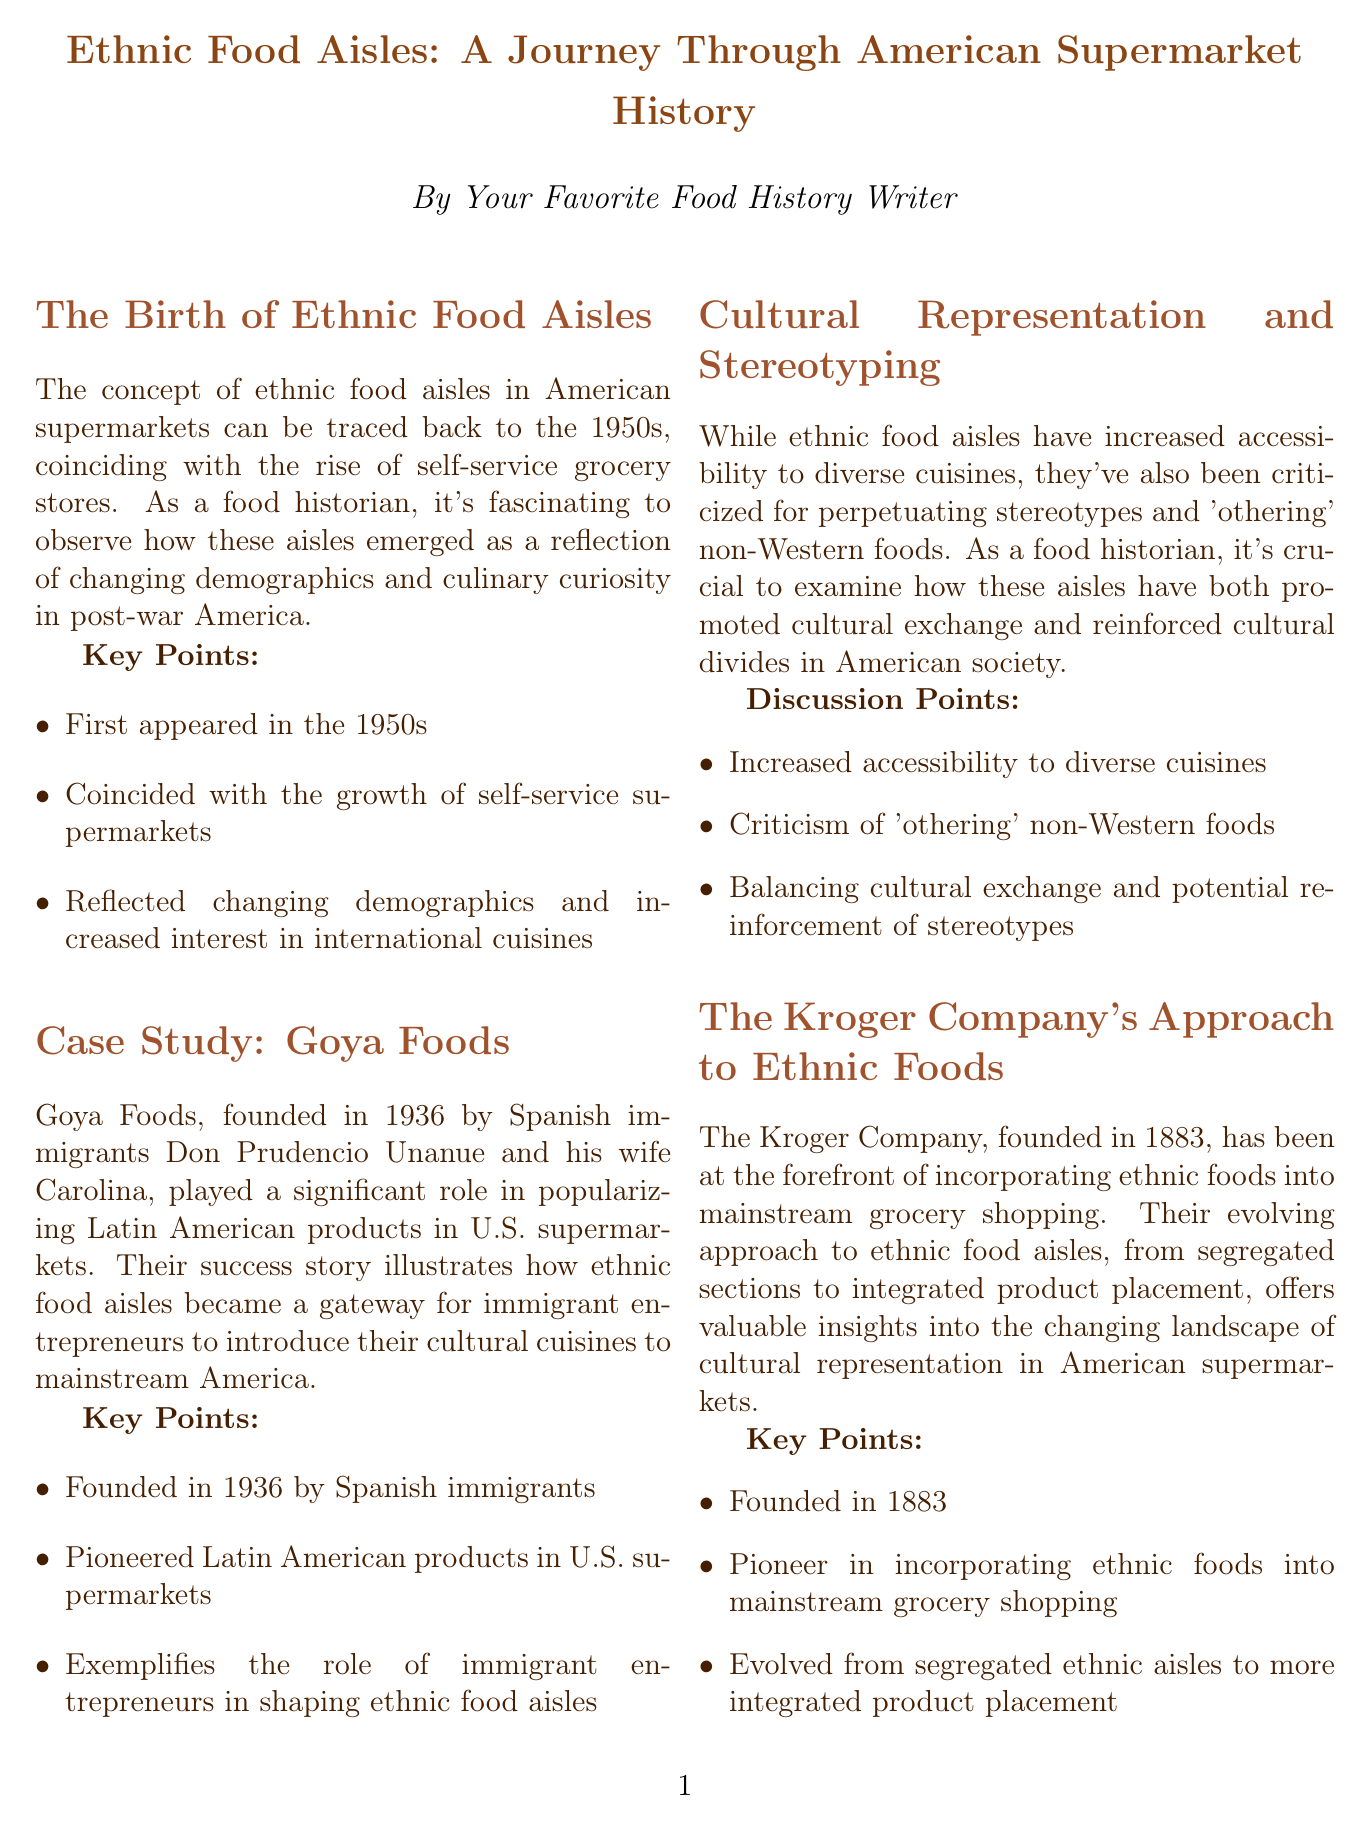What year did ethnic food aisles first appear? The document states that ethnic food aisles first appeared in the 1950s, highlighting a significant period in American supermarket history.
Answer: 1950s Who founded Goya Foods? The document mentions that Goya Foods was founded by Spanish immigrants Don Prudencio Unanue and his wife Carolina, emphasizing the immigrant entrepreneurial spirit.
Answer: Don Prudencio Unanue and Carolina What company has been a pioneer in incorporating ethnic foods into supermarkets? The document identifies Kroger as a pioneer in this area, showcasing its importance in the evolution of ethnic food aisles.
Answer: Kroger What controversy is mentioned regarding Trader Joe's? The document discusses the rebranding of Trader Joe's ethnic food line in 2020 as a specific instance highlighting cultural sensitivity issues.
Answer: 2020 rebranding What trend does Whole Foods Market follow in relation to ethnic food aisles? The document indicates that Whole Foods Market is moving towards a more integrated approach to ethnic food, signifying a shift in grocery retail practices.
Answer: Integrated approach What is a criticism of ethnic food aisles mentioned in the newsletter? The document points out that ethnic food aisles have been criticized for perpetuating stereotypes, raising important discussions about cultural representation.
Answer: Perpetuating stereotypes How long has Kroger been operating? The document specifies that the Kroger Company was founded in 1883, marking its long-standing presence in the grocery industry.
Answer: 1883 What role do ethnic food aisles play according to the case study of Goya Foods? The document illustrates that ethnic food aisles serve as a gateway for immigrant entrepreneurs to introduce their cultural cuisines to mainstream America.
Answer: Gateway for immigrant entrepreneurs What period coincided with the rise of self-service grocery stores? The document notes that the rise of ethnic food aisles coincided with the growth of self-service supermarkets, connecting food history with shopping trends.
Answer: 1950s 